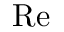Convert formula to latex. <formula><loc_0><loc_0><loc_500><loc_500>{ R e }</formula> 